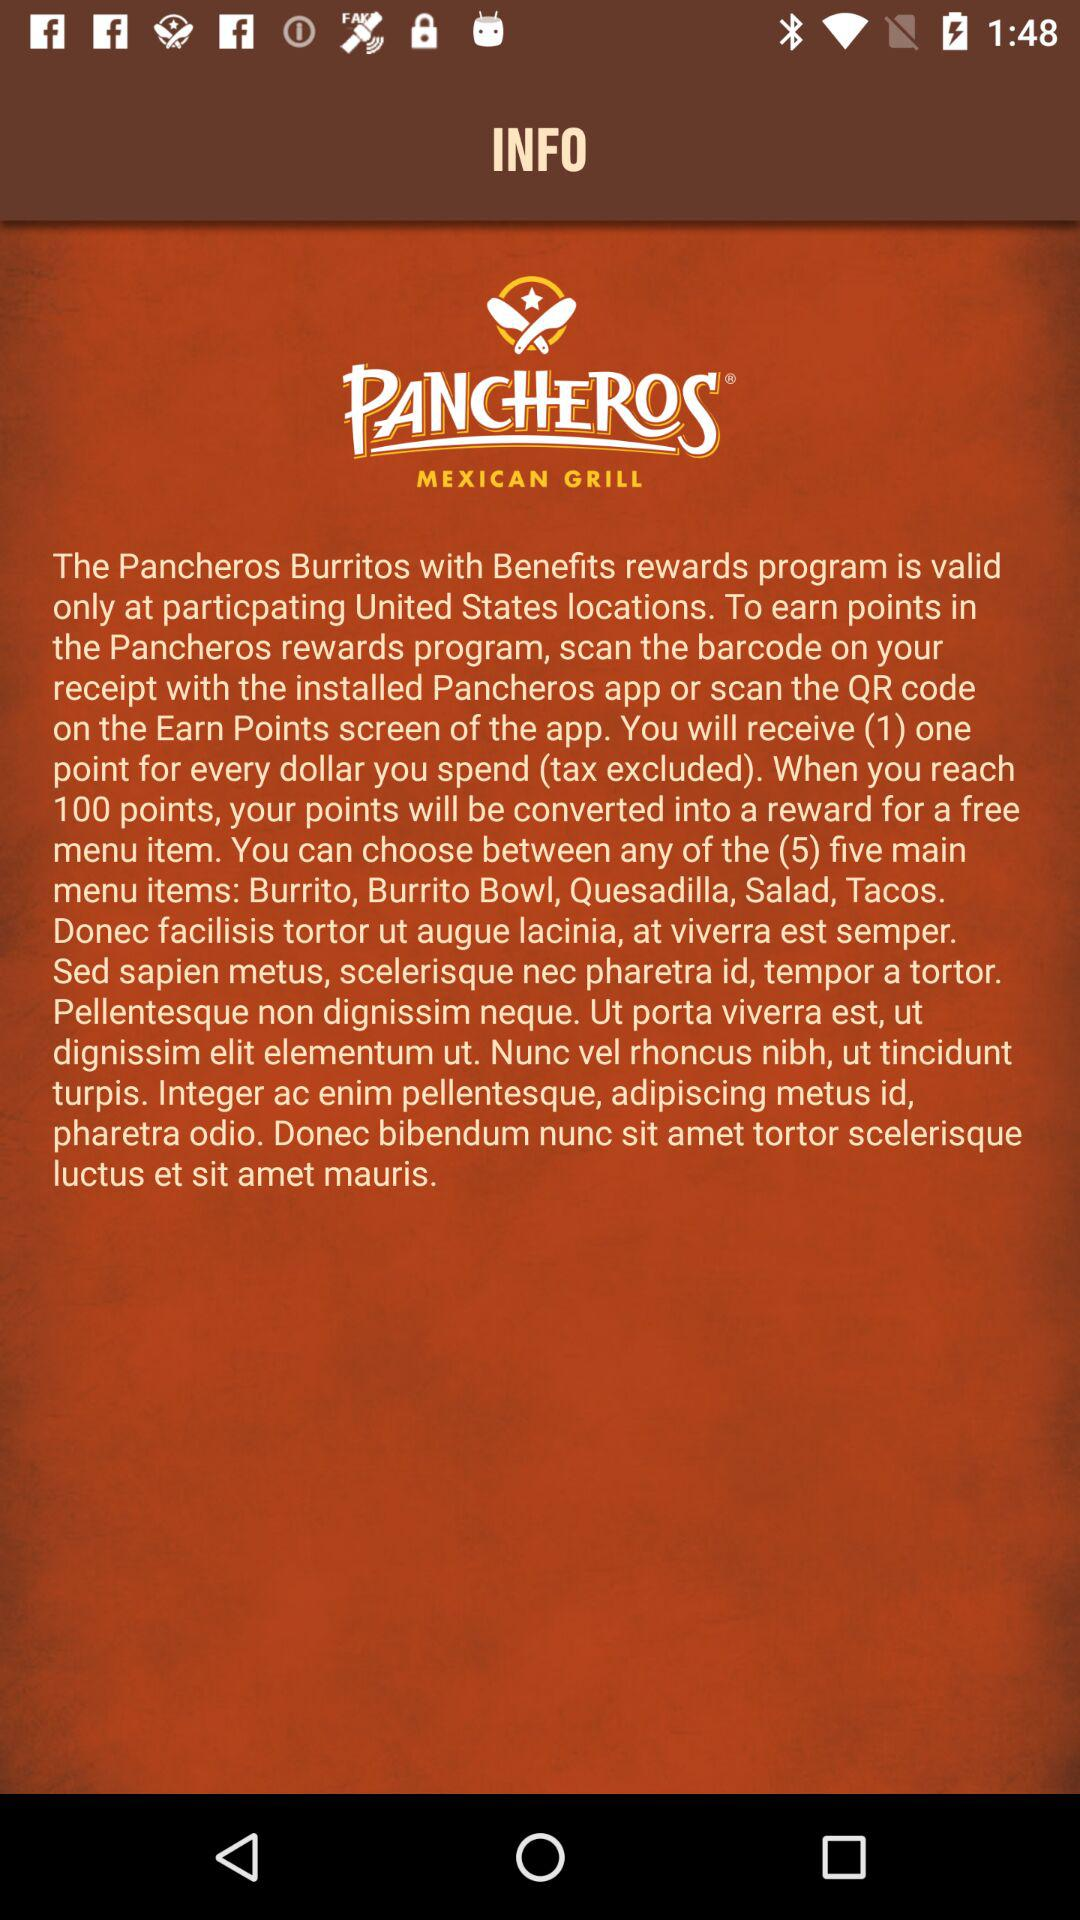How many points do you need to earn to get a free menu item?
Answer the question using a single word or phrase. 100 